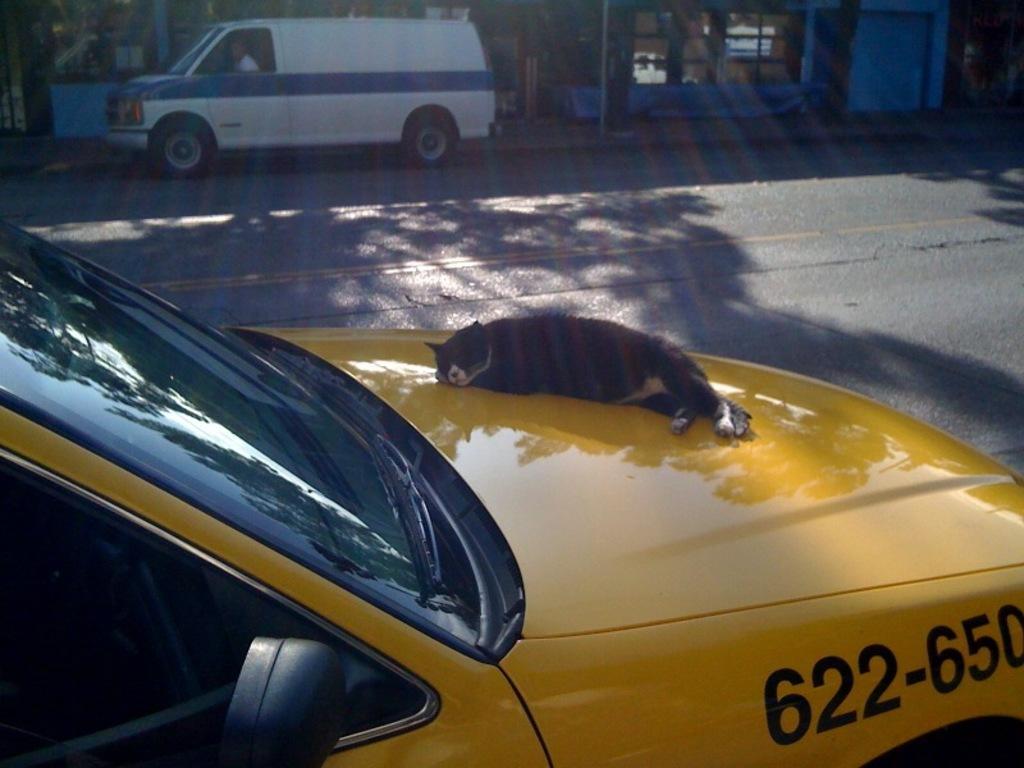How would you summarize this image in a sentence or two? In this picture there is a cat lying on a truncated vehicle and we can see the road. There is a person sitting inside a vehicle. In the background of the image it is blurry and we can see wall. 